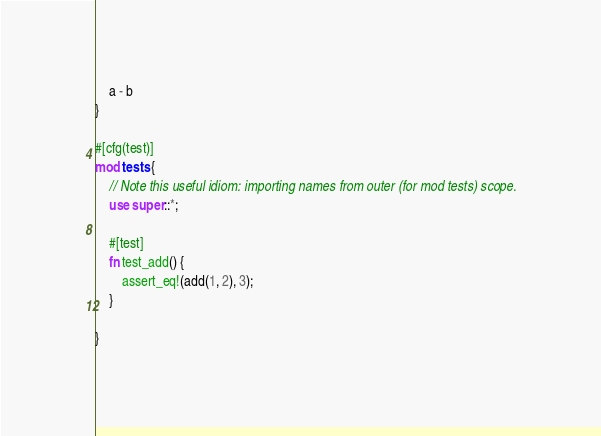<code> <loc_0><loc_0><loc_500><loc_500><_Rust_>    a - b
}

#[cfg(test)]
mod tests {
    // Note this useful idiom: importing names from outer (for mod tests) scope.
    use super::*;

    #[test]
    fn test_add() {
        assert_eq!(add(1, 2), 3);
    }

}
</code> 